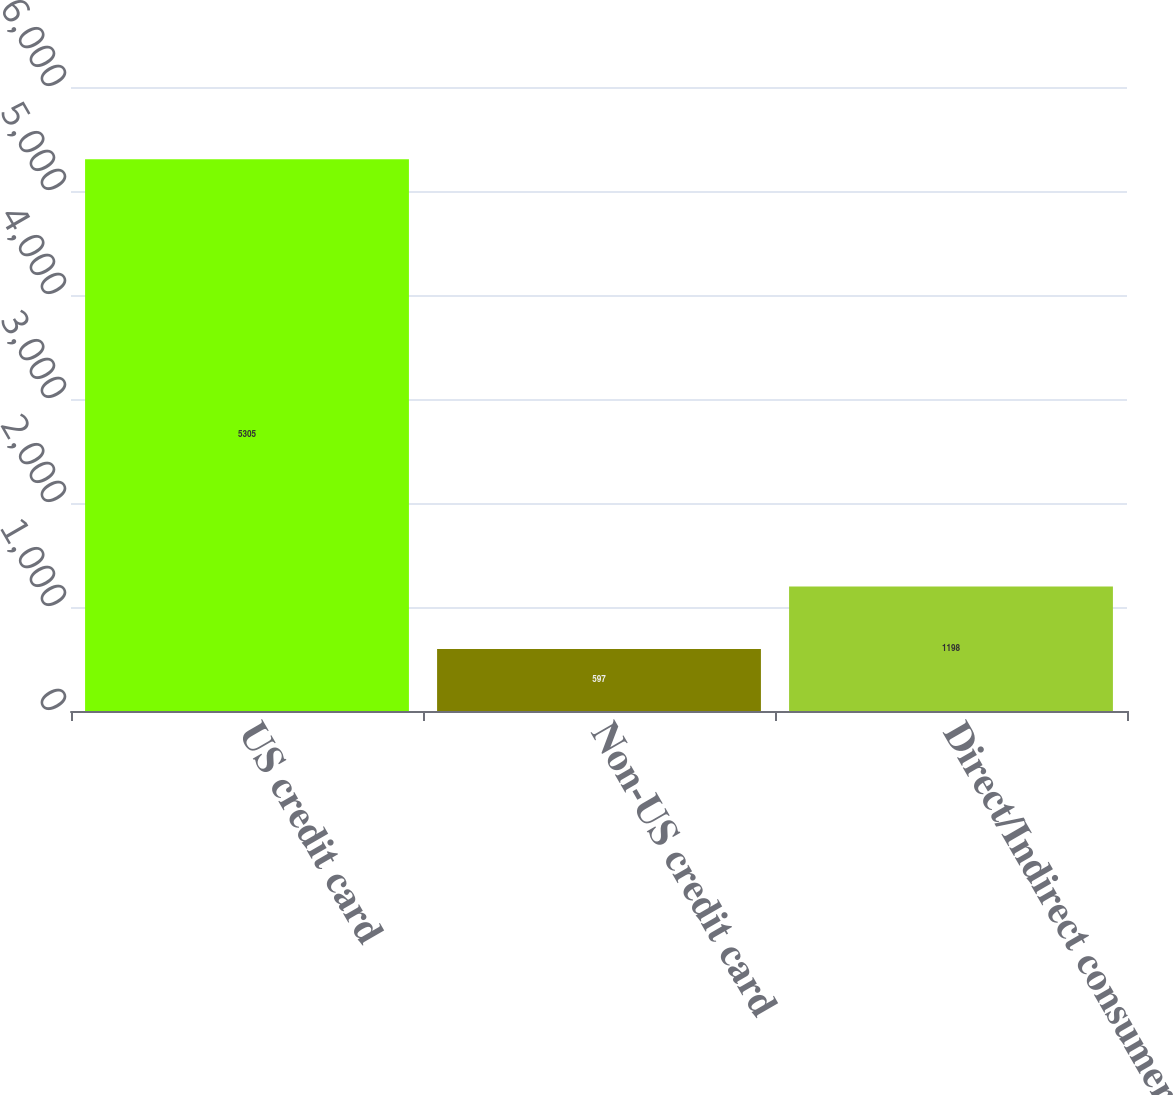<chart> <loc_0><loc_0><loc_500><loc_500><bar_chart><fcel>US credit card<fcel>Non-US credit card<fcel>Direct/Indirect consumer<nl><fcel>5305<fcel>597<fcel>1198<nl></chart> 